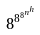<formula> <loc_0><loc_0><loc_500><loc_500>8 ^ { 8 ^ { 8 ^ { n ^ { h } } } }</formula> 